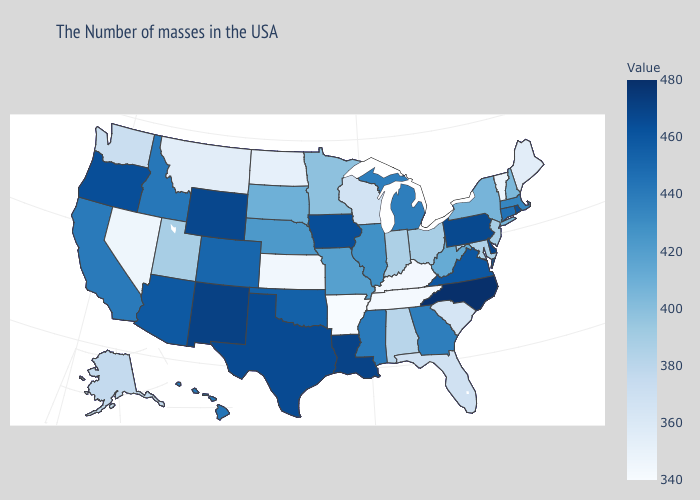Among the states that border Nebraska , does Missouri have the lowest value?
Short answer required. No. Among the states that border Illinois , does Kentucky have the lowest value?
Quick response, please. Yes. Is the legend a continuous bar?
Write a very short answer. Yes. Which states have the lowest value in the South?
Give a very brief answer. Arkansas. 